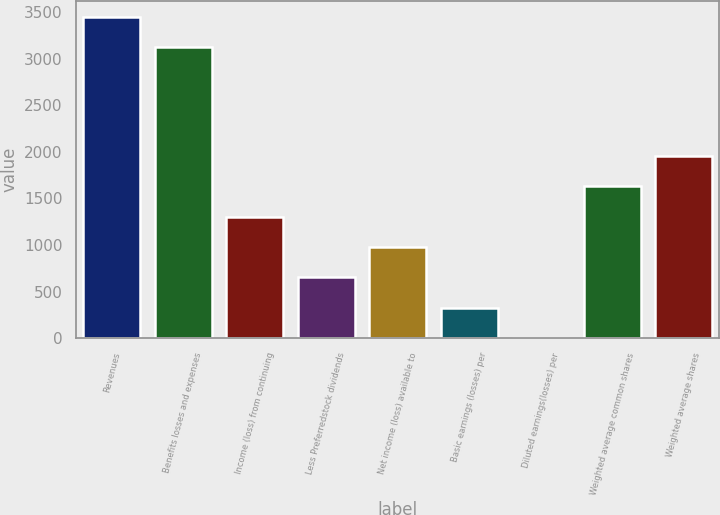Convert chart. <chart><loc_0><loc_0><loc_500><loc_500><bar_chart><fcel>Revenues<fcel>Benefits losses and expenses<fcel>Income (loss) from continuing<fcel>Less Preferredstock dividends<fcel>Net income (loss) available to<fcel>Basic earnings (losses) per<fcel>Diluted earnings(losses) per<fcel>Weighted average common shares<fcel>Weighted average shares<nl><fcel>3447.49<fcel>3121<fcel>1306.1<fcel>653.12<fcel>979.61<fcel>326.63<fcel>0.14<fcel>1632.59<fcel>1959.08<nl></chart> 